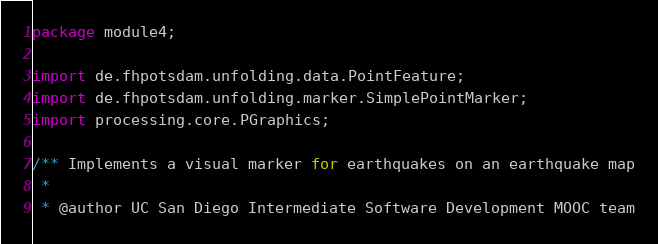Convert code to text. <code><loc_0><loc_0><loc_500><loc_500><_Java_>package module4;

import de.fhpotsdam.unfolding.data.PointFeature;
import de.fhpotsdam.unfolding.marker.SimplePointMarker;
import processing.core.PGraphics;

/** Implements a visual marker for earthquakes on an earthquake map
 * 
 * @author UC San Diego Intermediate Software Development MOOC team</code> 